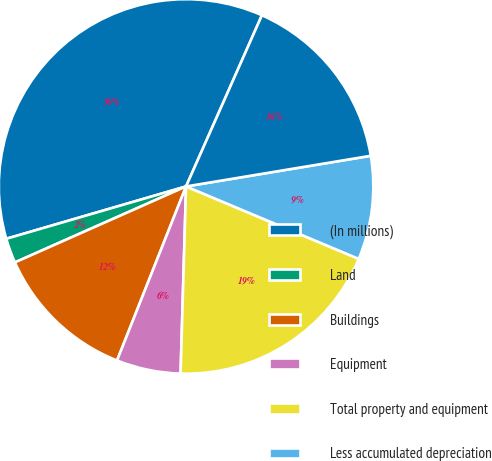<chart> <loc_0><loc_0><loc_500><loc_500><pie_chart><fcel>(In millions)<fcel>Land<fcel>Buildings<fcel>Equipment<fcel>Total property and equipment<fcel>Less accumulated depreciation<fcel>Net property and equipment<nl><fcel>36.14%<fcel>2.14%<fcel>12.34%<fcel>5.54%<fcel>19.14%<fcel>8.94%<fcel>15.74%<nl></chart> 